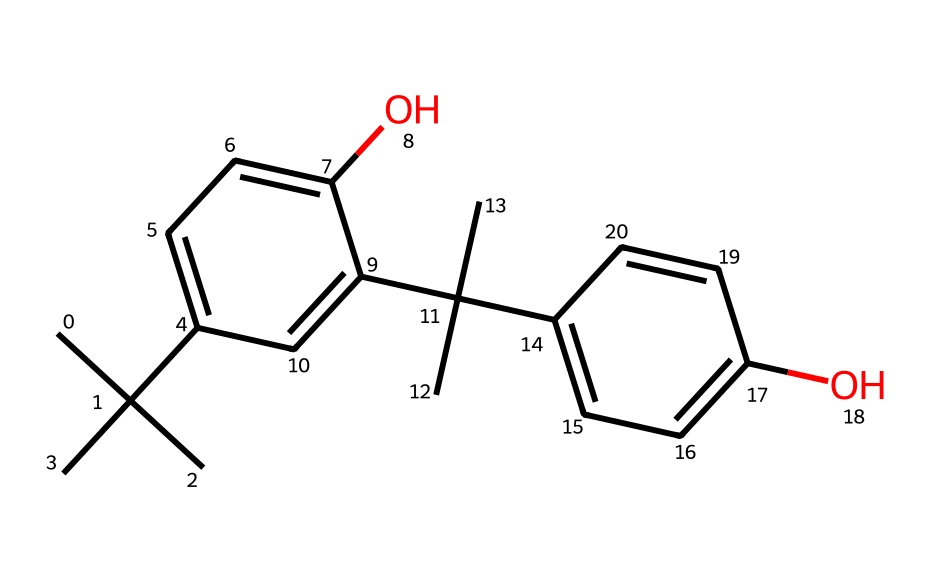What is the molecular formula of this chemical? By analyzing the structure, we can count the number of carbon (C), hydrogen (H), and oxygen (O) atoms. The structure has 22 carbon atoms, 30 hydrogen atoms, and 2 oxygen atoms. Therefore, the molecular formula is C22H30O2.
Answer: C22H30O2 How many benzene rings are present in this structure? The structure shows two distinct aromatic rings (benzene rings) that are recognizable by their alternating double bonds and hexagonal shape. Hence, there are two benzene rings.
Answer: 2 What functional groups can be identified in this molecule? Upon examining the chemical structure, we can see hydroxyl (–OH) groups that are attached to the benzene rings, making it a phenolic compound. Therefore, the identified functional group is hydroxyl.
Answer: hydroxyl What type of polymer is this compound classified as in photolithography? The presence of light-sensitive functional groups in the structure suggests that this compound behaves as a photoresist. Photoresists are typically polymers used in photolithography to create patterns on semiconductor substrates.
Answer: photoresist Which atoms in the structure are responsible for its light-sensitive properties? The light-sensitive properties are generally associated with the carbon atoms involved in the conjugated systems and the presence of hydroxyl groups. These groups can undergo chemical reactions when exposed to light.
Answer: carbon and hydroxyl What is the significance of the branched carbon chains in this molecule? The branched carbon chains provide steric hindrance and influence the solubility and reactivity of the polymer, which are important characteristics for its performance as a photoresist material.
Answer: steric hindrance and reactivity 